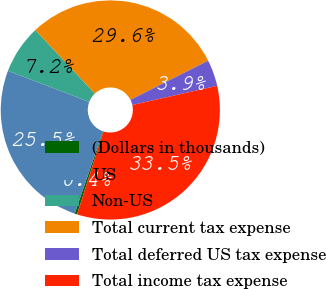<chart> <loc_0><loc_0><loc_500><loc_500><pie_chart><fcel>(Dollars in thousands)<fcel>US<fcel>Non-US<fcel>Total current tax expense<fcel>Total deferred US tax expense<fcel>Total income tax expense<nl><fcel>0.36%<fcel>25.55%<fcel>7.19%<fcel>29.57%<fcel>3.88%<fcel>33.45%<nl></chart> 